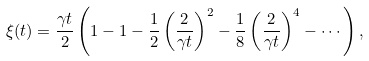<formula> <loc_0><loc_0><loc_500><loc_500>\xi ( t ) = \frac { \gamma t } { 2 } \left ( 1 - 1 - \frac { 1 } { 2 } \left ( \frac { 2 } { \gamma t } \right ) ^ { 2 } - \frac { 1 } { 8 } \left ( \frac { 2 } { \gamma t } \right ) ^ { 4 } - \cdots \right ) ,</formula> 